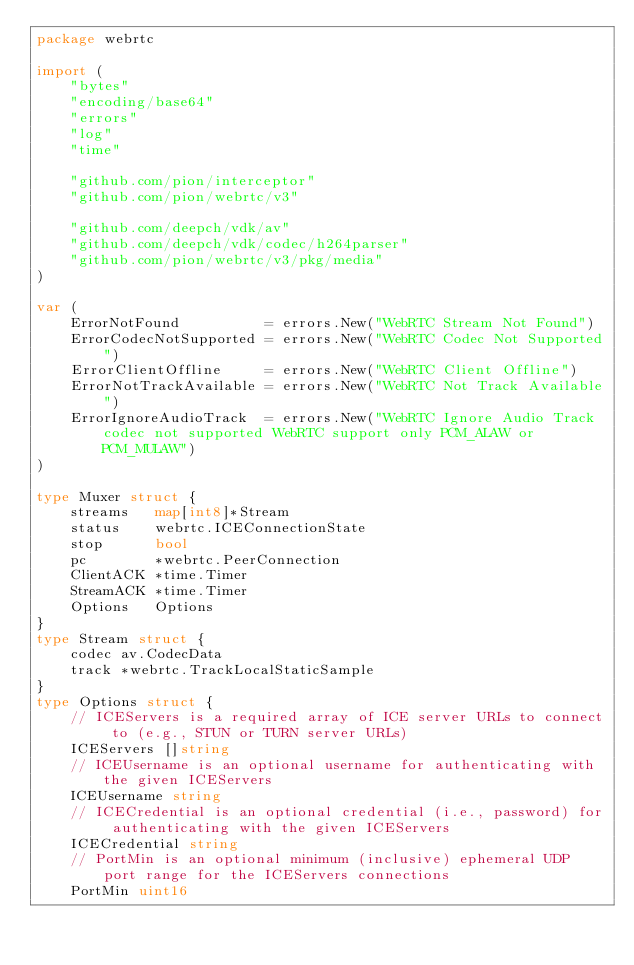Convert code to text. <code><loc_0><loc_0><loc_500><loc_500><_Go_>package webrtc

import (
	"bytes"
	"encoding/base64"
	"errors"
	"log"
	"time"

	"github.com/pion/interceptor"
	"github.com/pion/webrtc/v3"

	"github.com/deepch/vdk/av"
	"github.com/deepch/vdk/codec/h264parser"
	"github.com/pion/webrtc/v3/pkg/media"
)

var (
	ErrorNotFound          = errors.New("WebRTC Stream Not Found")
	ErrorCodecNotSupported = errors.New("WebRTC Codec Not Supported")
	ErrorClientOffline     = errors.New("WebRTC Client Offline")
	ErrorNotTrackAvailable = errors.New("WebRTC Not Track Available")
	ErrorIgnoreAudioTrack  = errors.New("WebRTC Ignore Audio Track codec not supported WebRTC support only PCM_ALAW or PCM_MULAW")
)

type Muxer struct {
	streams   map[int8]*Stream
	status    webrtc.ICEConnectionState
	stop      bool
	pc        *webrtc.PeerConnection
	ClientACK *time.Timer
	StreamACK *time.Timer
	Options   Options
}
type Stream struct {
	codec av.CodecData
	track *webrtc.TrackLocalStaticSample
}
type Options struct {
	// ICEServers is a required array of ICE server URLs to connect to (e.g., STUN or TURN server URLs)
	ICEServers []string
	// ICEUsername is an optional username for authenticating with the given ICEServers
	ICEUsername string
	// ICECredential is an optional credential (i.e., password) for authenticating with the given ICEServers
	ICECredential string
	// PortMin is an optional minimum (inclusive) ephemeral UDP port range for the ICEServers connections
	PortMin uint16</code> 